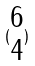Convert formula to latex. <formula><loc_0><loc_0><loc_500><loc_500>( \begin{matrix} 6 \\ 4 \end{matrix} )</formula> 